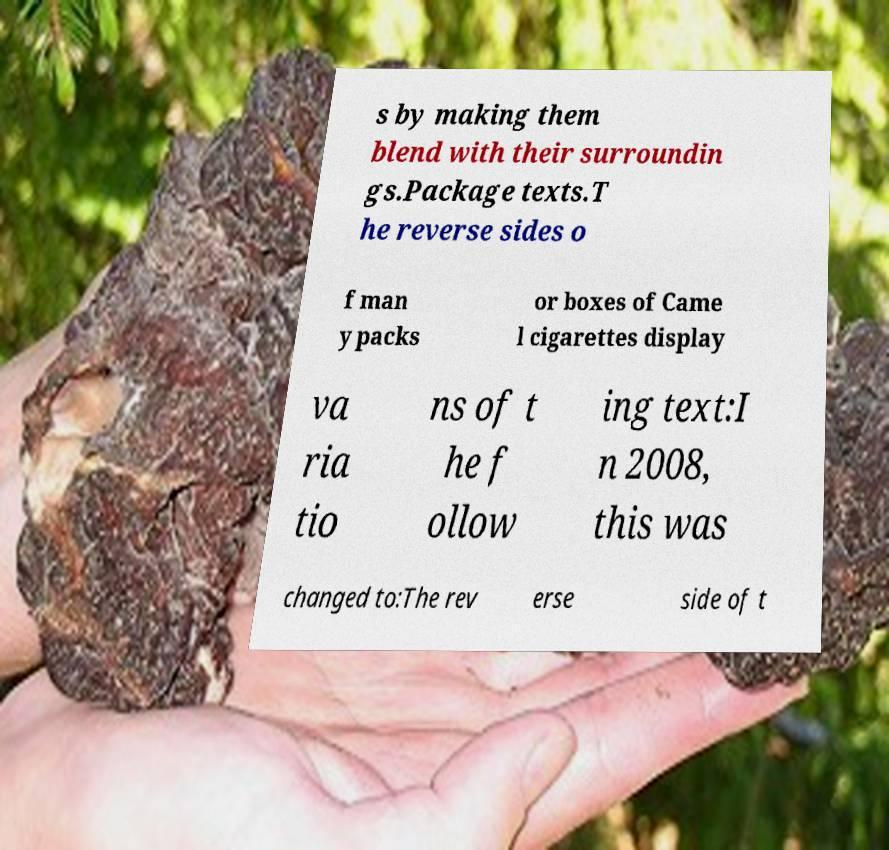What messages or text are displayed in this image? I need them in a readable, typed format. s by making them blend with their surroundin gs.Package texts.T he reverse sides o f man y packs or boxes of Came l cigarettes display va ria tio ns of t he f ollow ing text:I n 2008, this was changed to:The rev erse side of t 